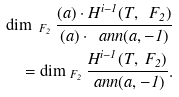Convert formula to latex. <formula><loc_0><loc_0><loc_500><loc_500>\dim _ { \ F _ { 2 } } \frac { ( a ) \cdot H ^ { i - 1 } ( T , \ F _ { 2 } ) } { ( a ) \cdot \ a n n ( a , - 1 ) } \\ = \dim _ { \ F _ { 2 } } \frac { H ^ { i - 1 } ( T , \ F _ { 2 } ) } { \ a n n ( a , - 1 ) } .</formula> 